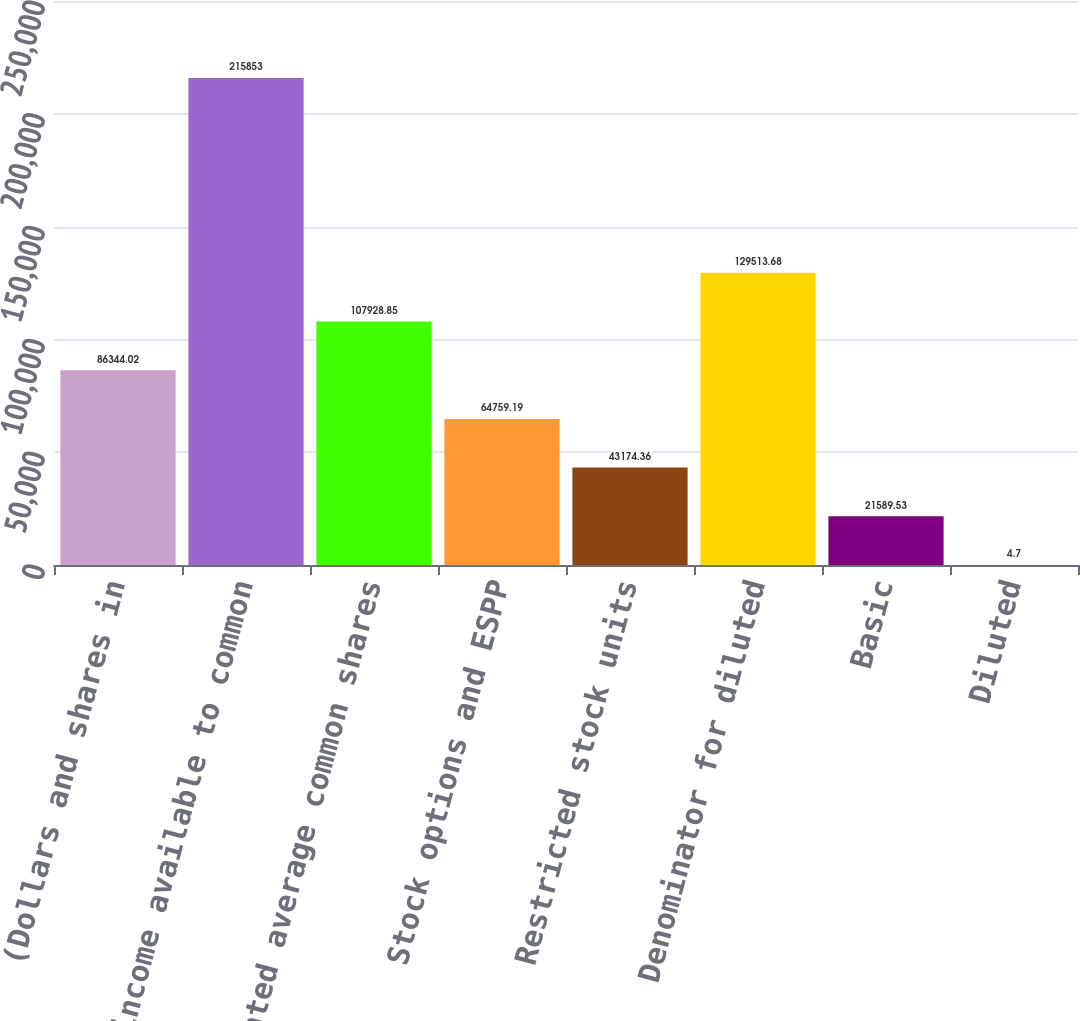Convert chart to OTSL. <chart><loc_0><loc_0><loc_500><loc_500><bar_chart><fcel>(Dollars and shares in<fcel>Net income available to common<fcel>Weighted average common shares<fcel>Stock options and ESPP<fcel>Restricted stock units<fcel>Denominator for diluted<fcel>Basic<fcel>Diluted<nl><fcel>86344<fcel>215853<fcel>107929<fcel>64759.2<fcel>43174.4<fcel>129514<fcel>21589.5<fcel>4.7<nl></chart> 